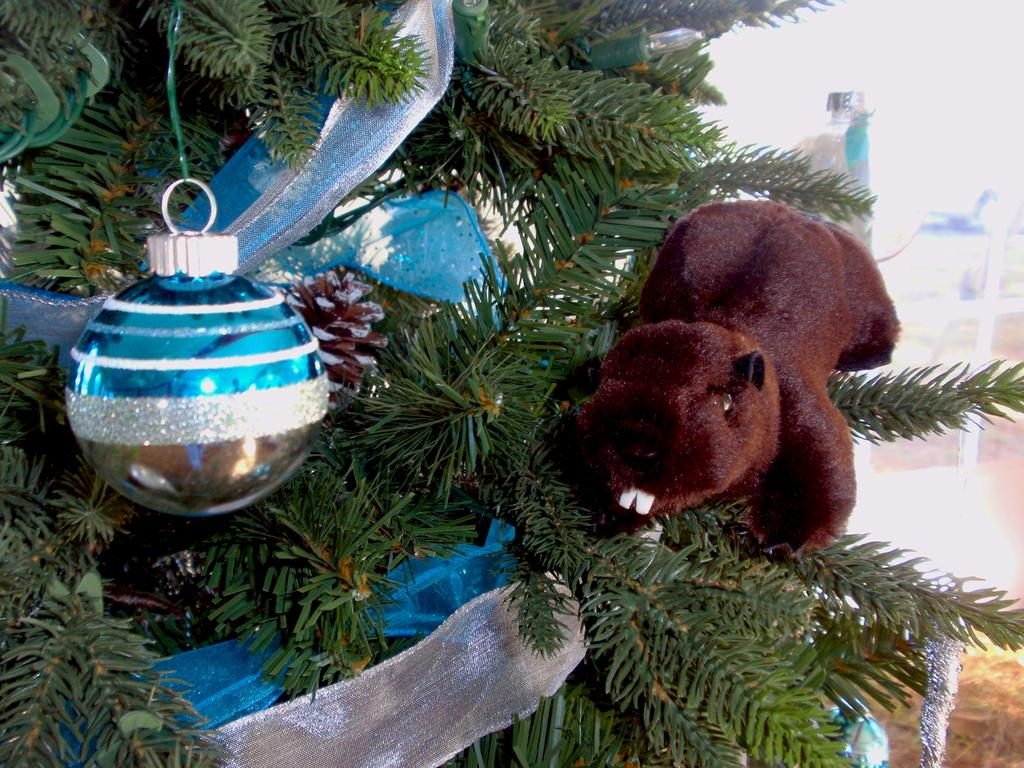What type of tree is in the image? There is a Christmas tree in the image. What decorations are on the Christmas tree? The Christmas tree has ribbons. What other object can be seen near the Christmas tree? There is a soft toy near the Christmas tree. What type of wall decoration is present in the image? There is a decorative wall hanging in the image. How many spiders are crawling on the Christmas tree in the image? There are no spiders present on the Christmas tree in the image. What type of kite is hanging from the ceiling in the image? There is no kite present in the image. 